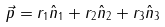Convert formula to latex. <formula><loc_0><loc_0><loc_500><loc_500>\vec { p } = r _ { 1 } \hat { n } _ { 1 } + r _ { 2 } \hat { n } _ { 2 } + r _ { 3 } \hat { n } _ { 3 }</formula> 